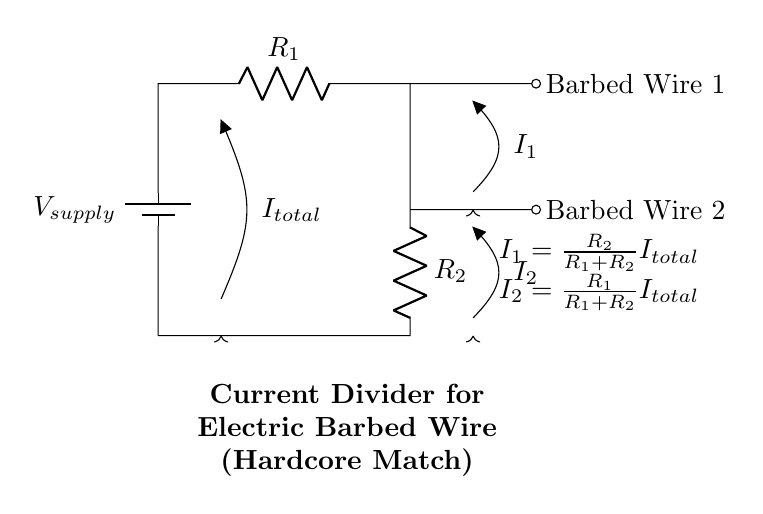What is the voltage source in this circuit? The voltage source is represented by the battery symbol labeled V_supply, providing the input voltage necessary for the circuit.
Answer: V_supply What are the resistances in the circuit? The circuit has two resistors: R_1 and R_2, each of which is labeled near its respective symbol, indicating their presence and values.
Answer: R_1, R_2 What is the total current flowing through the circuit? The total current is labeled as I_total, and it is indicated by the arrow pointing downward from the top of the circuit, representing the current entering the divider.
Answer: I_total How is the current divided between the two branches? The current is divided according to the values of the resistors according to the formulas: I_1 is proportional to R_2 and I_2 is proportional to R_1, reflecting the current divider rule.
Answer: I_1 and I_2 How can you calculate the current through Barbed Wire 1? The current through Barbed Wire 1 (I_1) can be calculated using the formula I_1 = (R_2 / (R_1 + R_2)) * I_total, which reflects the relationship between the resistors and total current.
Answer: I_1 = (R_2 / (R_1 + R_2)) * I_total What happens if R_1 is much larger than R_2? If R_1 is much larger than R_2, most of the current will flow through Barbed Wire 2, resulting in I_1 being small while I_2 becomes close to I_total, as per the current divider principle.
Answer: I_2 ≈ I_total, I_1 ≈ 0 How can you increase the current through Barbed Wire 2? To increase the current through Barbed Wire 2 (I_2), you can decrease the resistance R_1 since a lower resistance in that branch will allow more current to flow according to the current divider rule.
Answer: Decrease R_1 